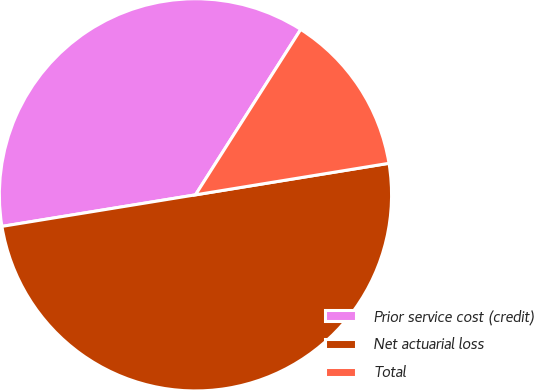Convert chart to OTSL. <chart><loc_0><loc_0><loc_500><loc_500><pie_chart><fcel>Prior service cost (credit)<fcel>Net actuarial loss<fcel>Total<nl><fcel>36.59%<fcel>50.0%<fcel>13.41%<nl></chart> 